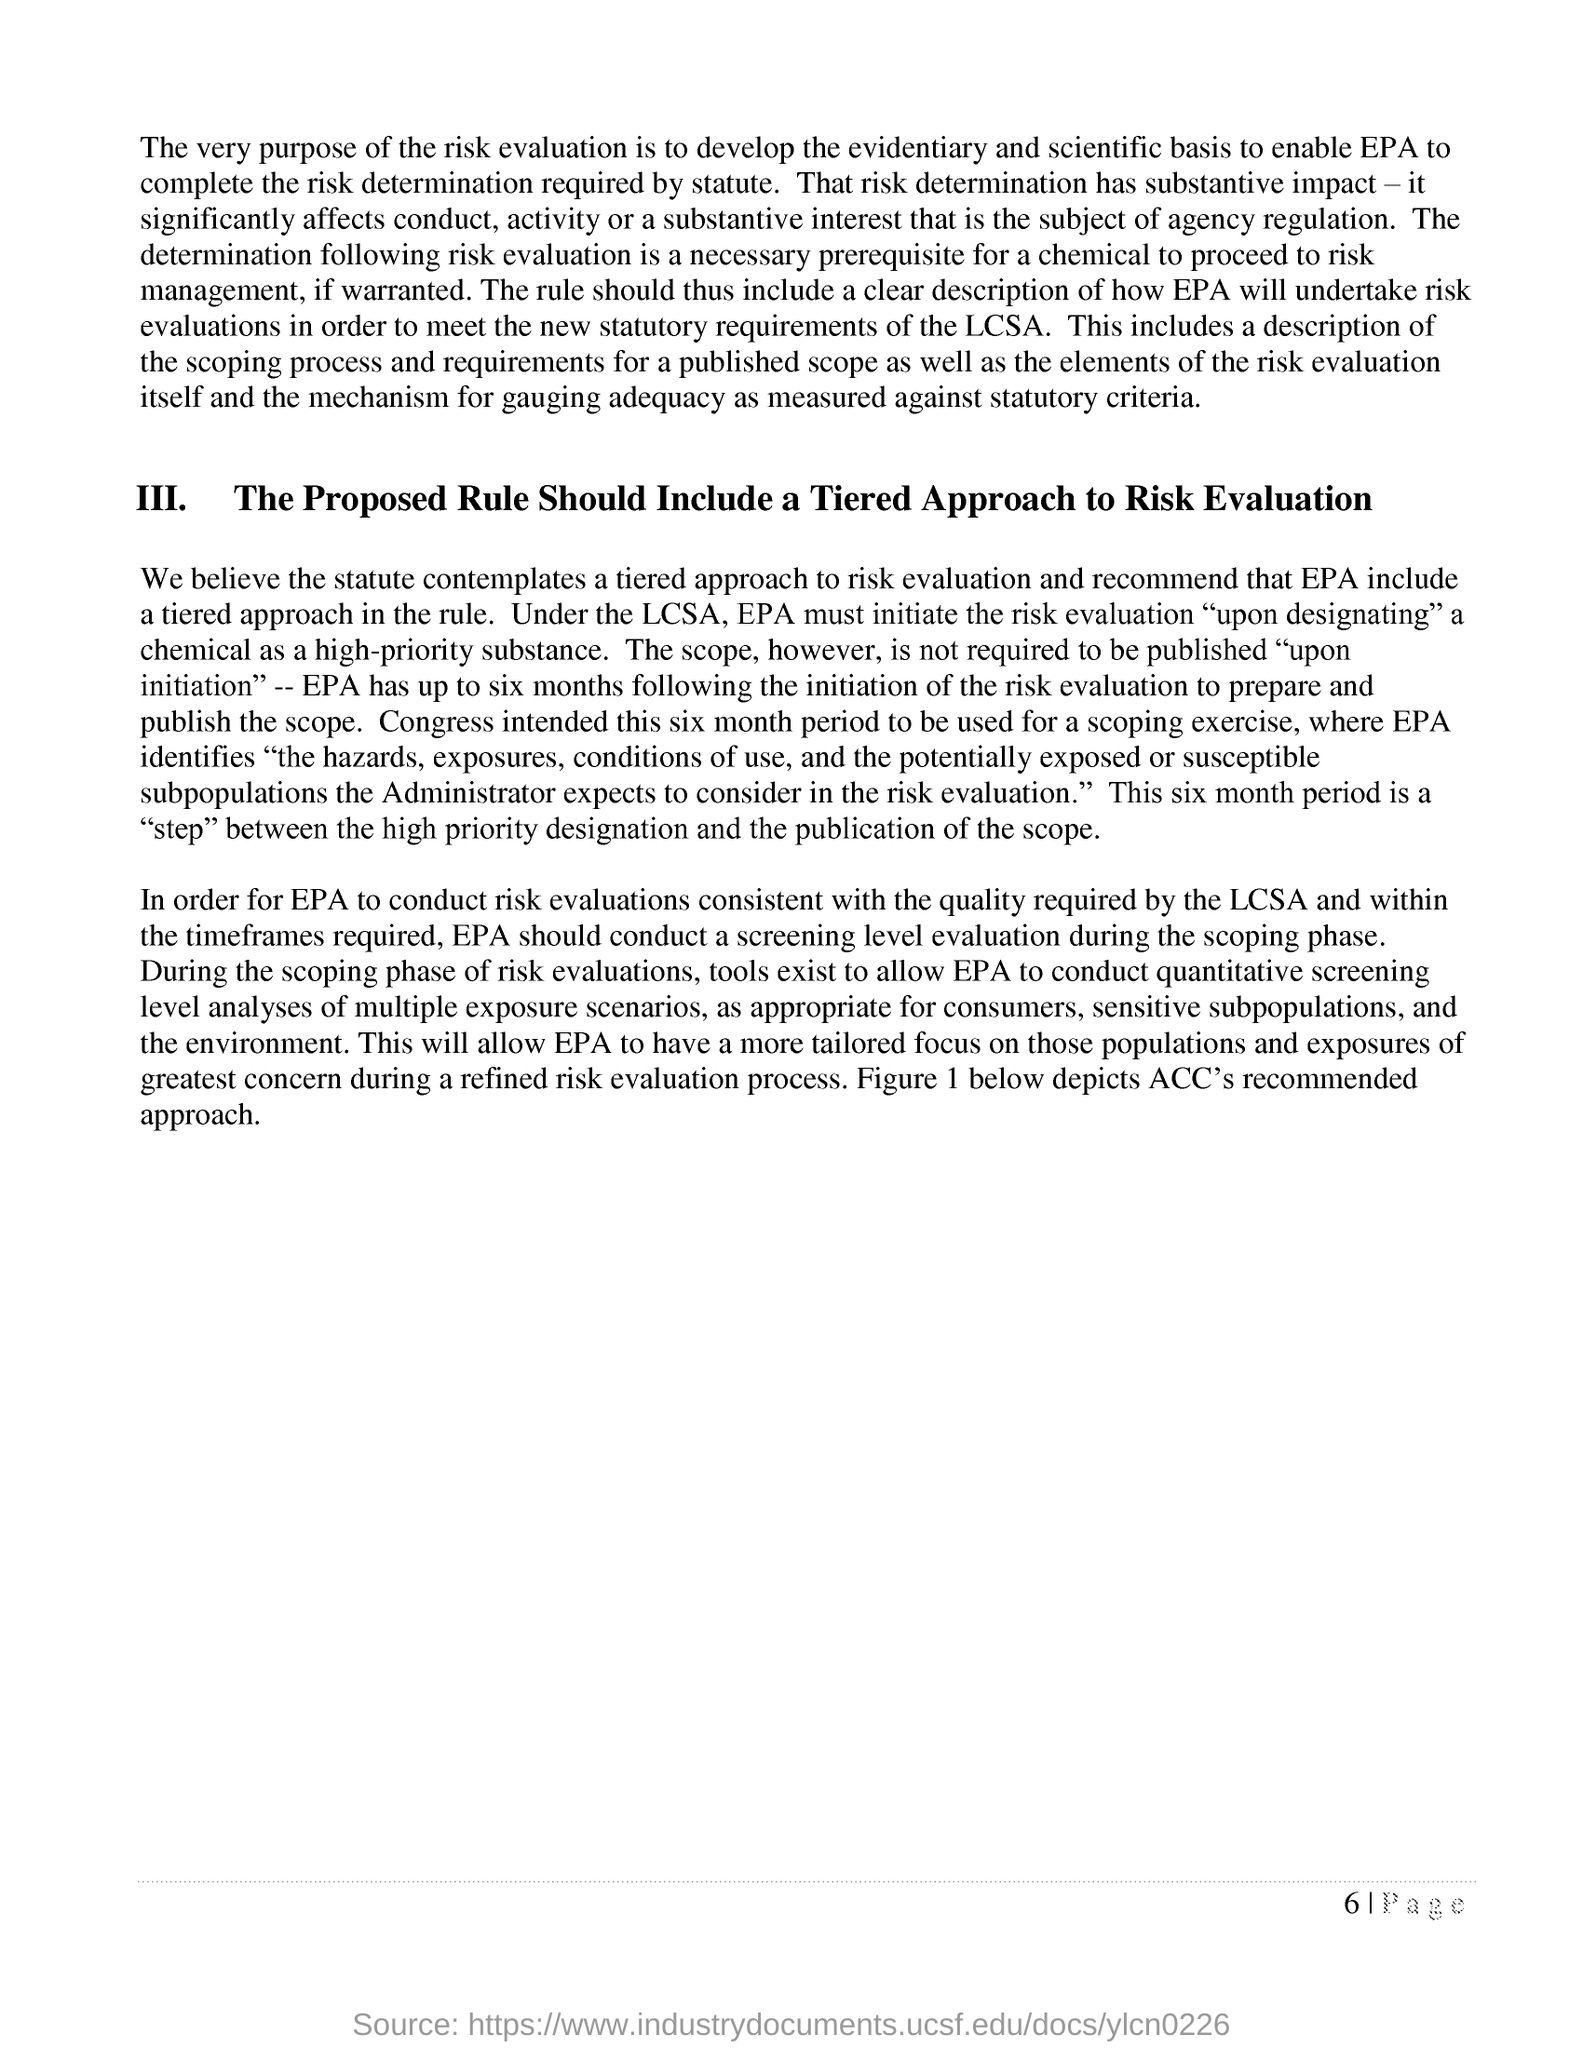Mention a couple of crucial points in this snapshot. The proposed rule should include a tiered approach to risk evaluation, as emphasized in bold letters in the heading III. Figure 1 below depicts the recommended approach by the American College of Cardiology for the management of acute coronary syndromes. 